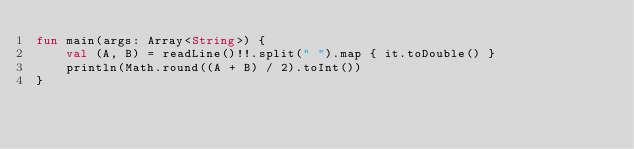Convert code to text. <code><loc_0><loc_0><loc_500><loc_500><_Kotlin_>fun main(args: Array<String>) {
    val (A, B) = readLine()!!.split(" ").map { it.toDouble() }
    println(Math.round((A + B) / 2).toInt())
}
</code> 